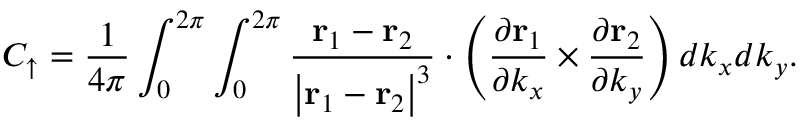<formula> <loc_0><loc_0><loc_500><loc_500>C _ { \uparrow } = \frac { 1 } { 4 \pi } \int _ { 0 } ^ { 2 \pi } \int _ { 0 } ^ { 2 \pi } \frac { r _ { 1 } - r _ { 2 } } { \left | r _ { 1 } - r _ { 2 } \right | ^ { 3 } } \cdot \left ( \frac { \partial r _ { 1 } } { \partial k _ { x } } \times \frac { \partial r _ { 2 } } { \partial k _ { y } } \right ) d k _ { x } d k _ { y } .</formula> 